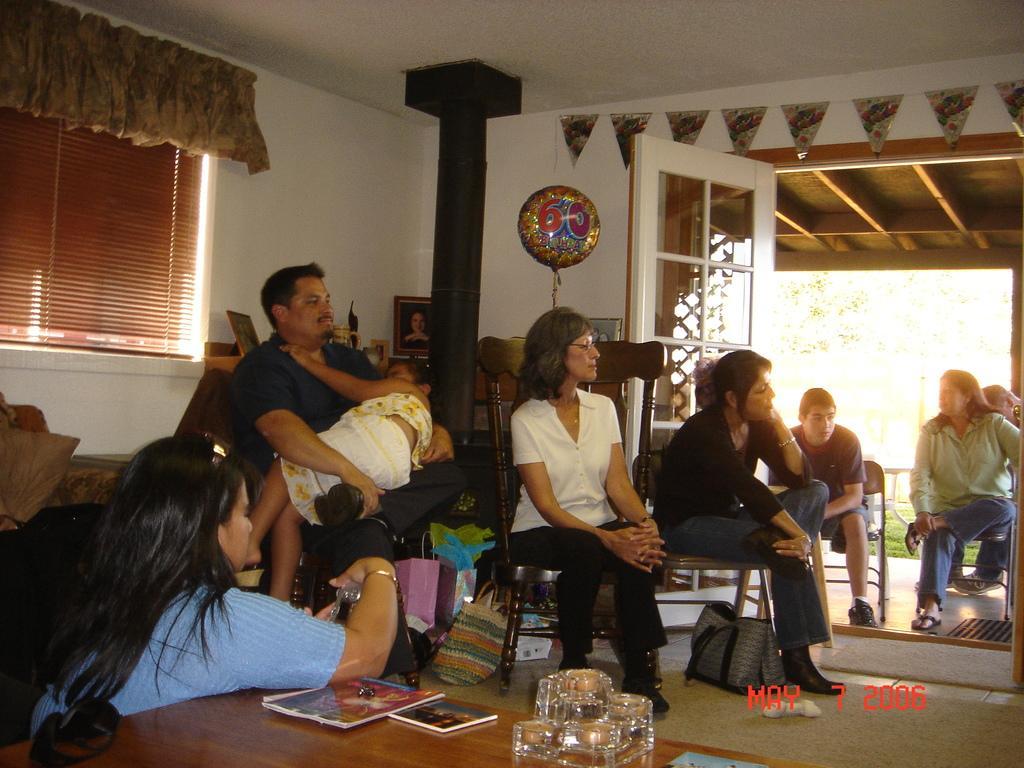Can you describe this image briefly? In this image we can see people are sitting on chairs. In the background we can see window blinds, photo frames on table, balloon and doors. 